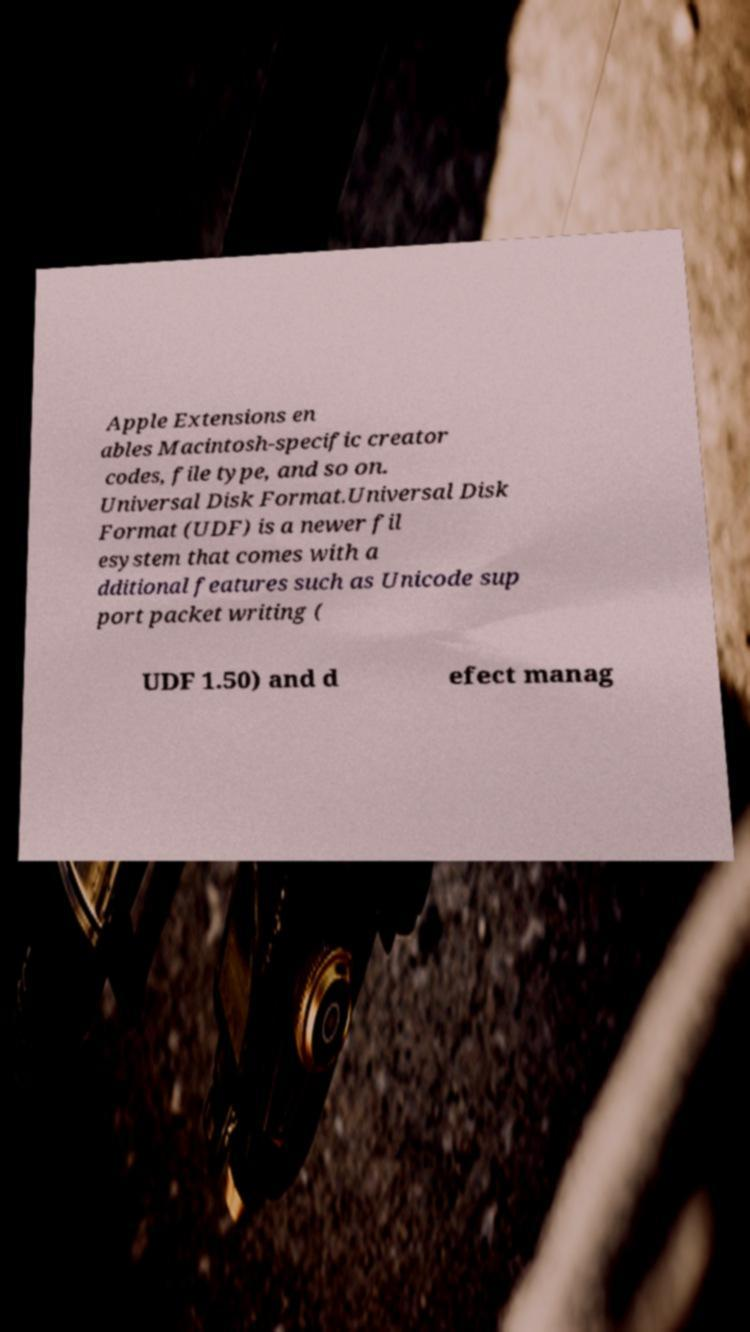For documentation purposes, I need the text within this image transcribed. Could you provide that? Apple Extensions en ables Macintosh-specific creator codes, file type, and so on. Universal Disk Format.Universal Disk Format (UDF) is a newer fil esystem that comes with a dditional features such as Unicode sup port packet writing ( UDF 1.50) and d efect manag 